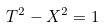<formula> <loc_0><loc_0><loc_500><loc_500>T ^ { 2 } - X ^ { 2 } = 1</formula> 